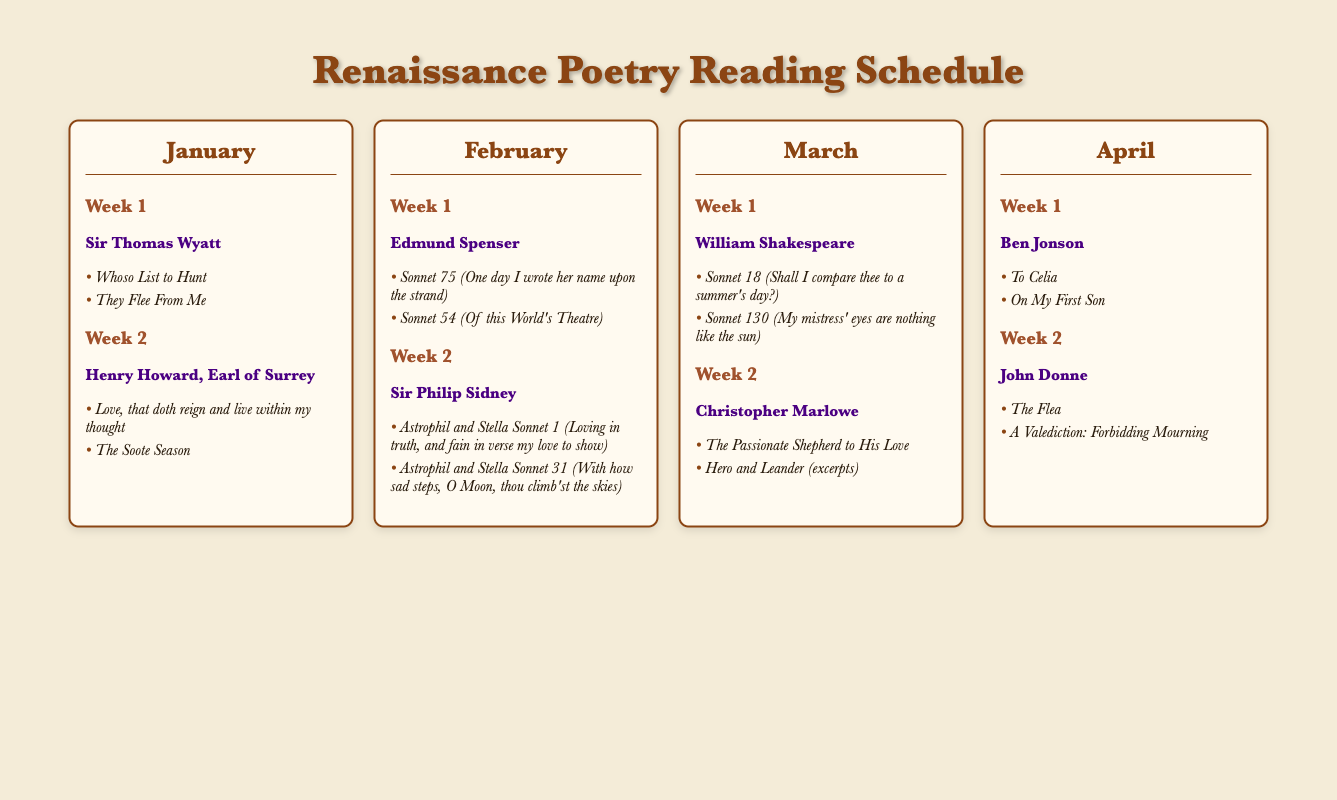What poet is featured in the first week of January? The document lists Sir Thomas Wyatt as the featured poet in the first week of January.
Answer: Sir Thomas Wyatt Which poem does Henry Howard, Earl of Surrey, have in the second week of January? The document highlights "Love, that doth reign and live within my thought" as one of the poems for Henry Howard, Earl of Surrey in January.
Answer: Love, that doth reign and live within my thought How many poems are listed for John Donne in April? The document specifies that two poems are provided for John Donne in April.
Answer: 2 What is the title of William Shakespeare's famous sonnet included in March? The document indicates that "Sonnet 18 (Shall I compare thee to a summer's day?)" is one of Shakespeare's sonnets featured in March.
Answer: Sonnet 18 (Shall I compare thee to a summer's day?) Which poet features in Week 1 of February? The document identifies Edmund Spenser as the poet for Week 1 of February.
Answer: Edmund Spenser What month features Ben Jonson's work in the schedule? According to the document, Ben Jonson's work is included in the month of April.
Answer: April Which poem by Christopher Marlowe is featured in March? The document highlights "The Passionate Shepherd to His Love" as one of Marlowe's poems featured in March.
Answer: The Passionate Shepherd to His Love 